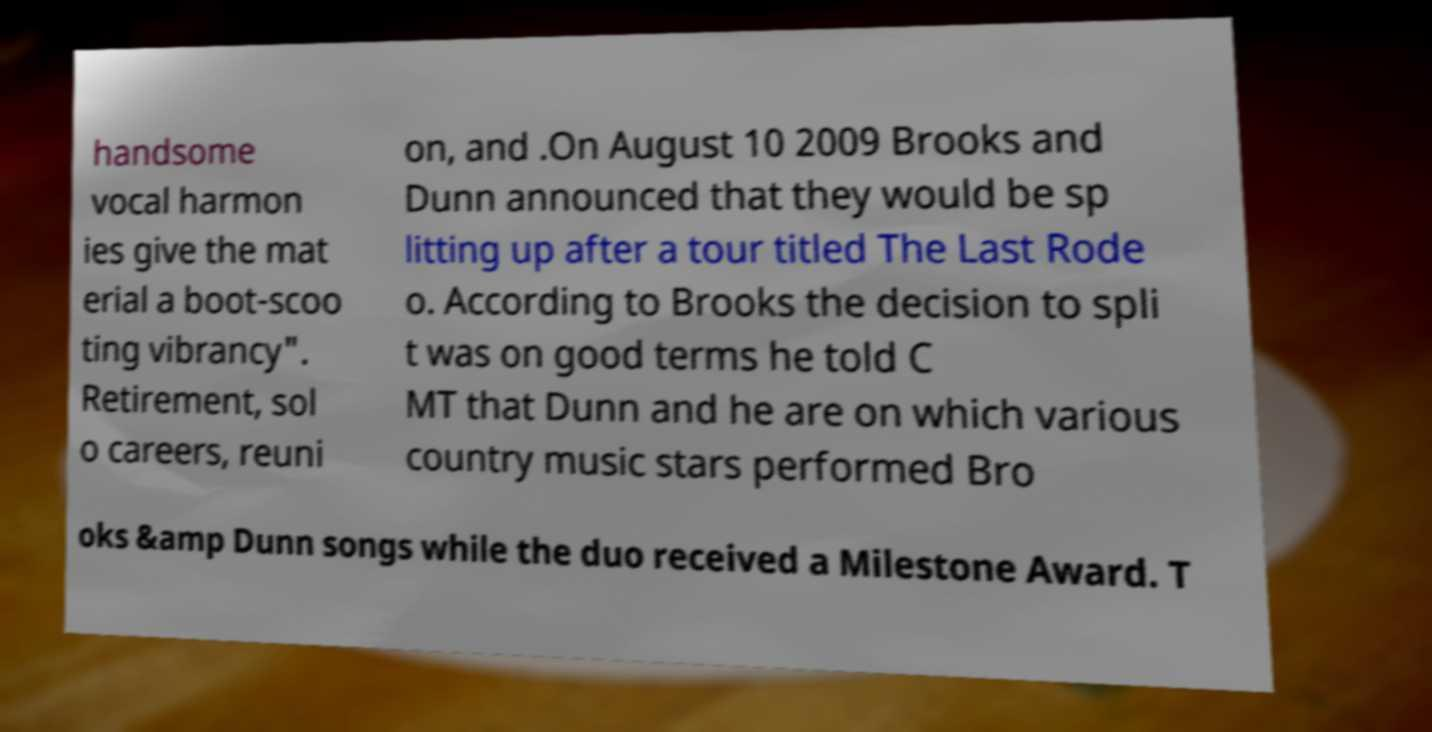Can you accurately transcribe the text from the provided image for me? handsome vocal harmon ies give the mat erial a boot-scoo ting vibrancy". Retirement, sol o careers, reuni on, and .On August 10 2009 Brooks and Dunn announced that they would be sp litting up after a tour titled The Last Rode o. According to Brooks the decision to spli t was on good terms he told C MT that Dunn and he are on which various country music stars performed Bro oks &amp Dunn songs while the duo received a Milestone Award. T 